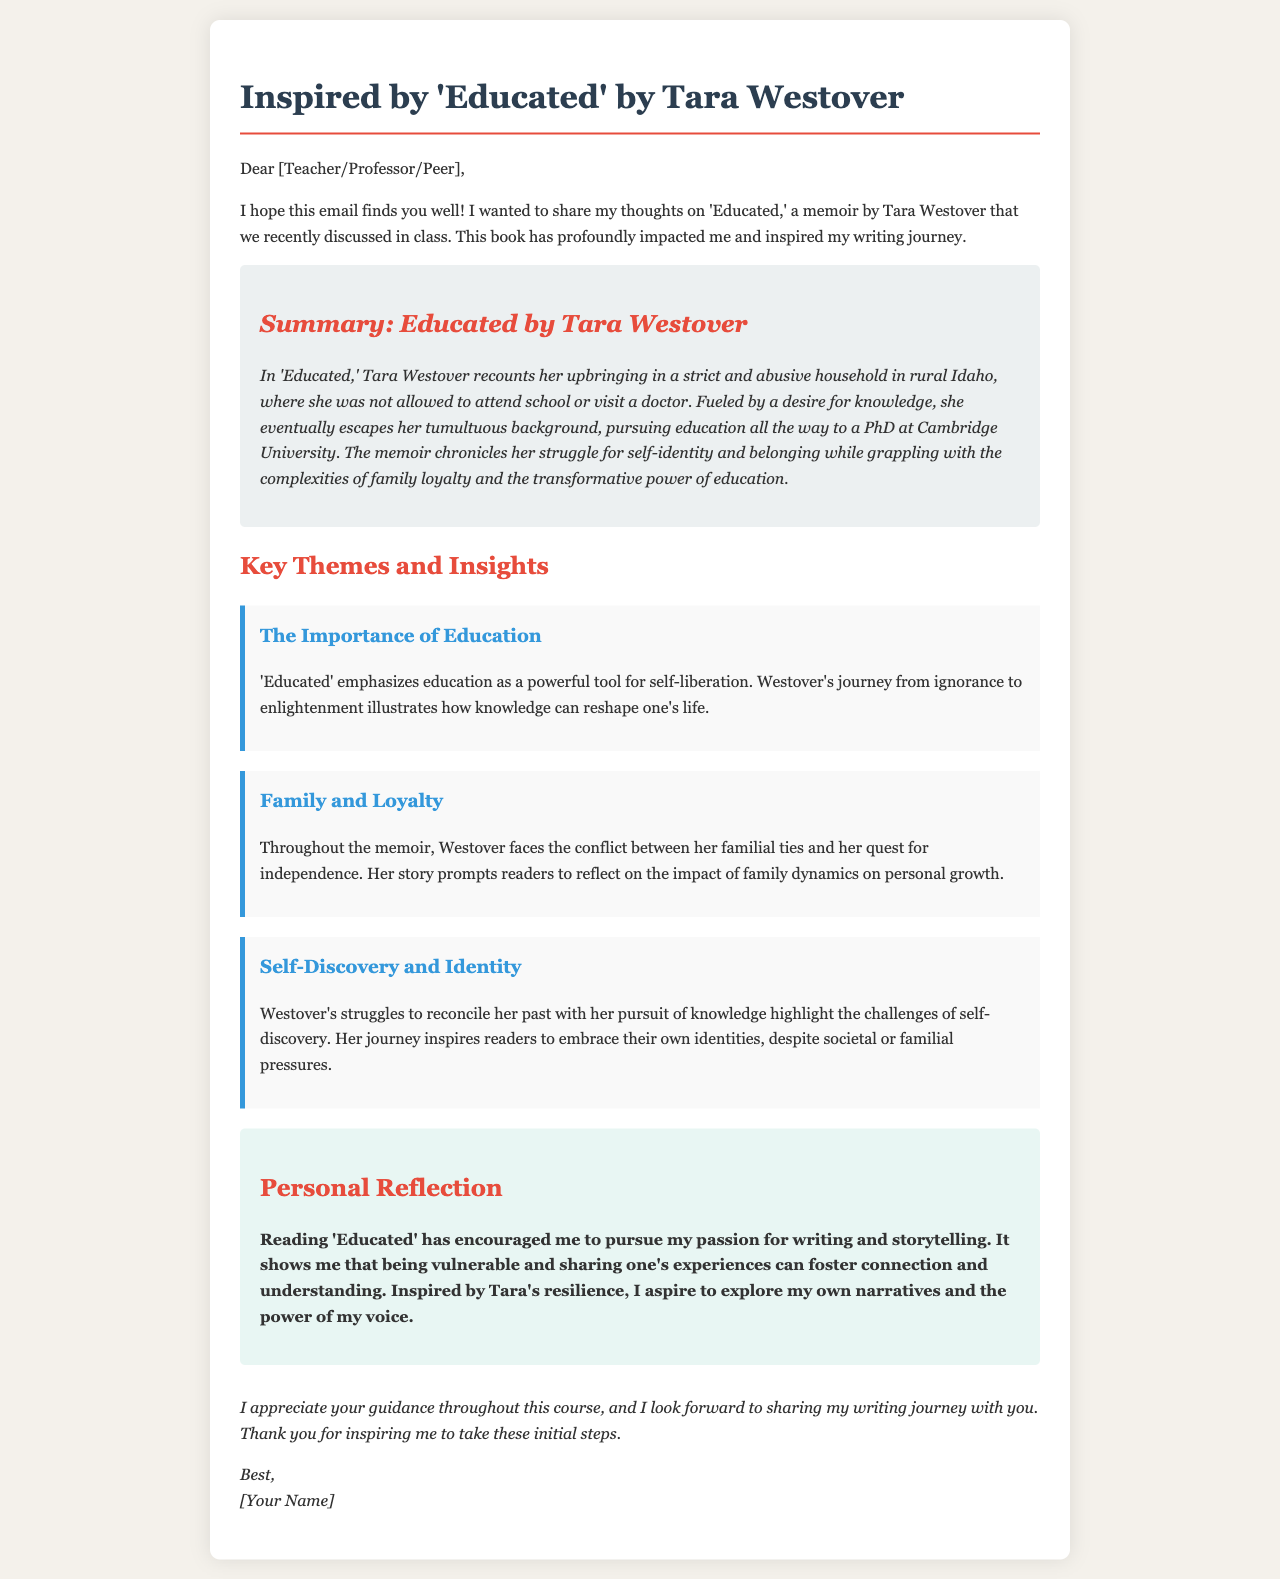What is the title of the memoir discussed? The title of the memoir mentioned in the document is 'Educated'.
Answer: 'Educated' Who is the author of the memoir? The author of the memoir is Tara Westover.
Answer: Tara Westover What is one of the key themes highlighted in the document? One of the key themes highlighted is the importance of education.
Answer: Importance of Education What degree did Tara Westover earn? Tara Westover earned a PhD.
Answer: PhD What impact did reading 'Educated' have on the author of the email? Reading 'Educated' encouraged the author to pursue writing and storytelling.
Answer: Pursue writing and storytelling How does the document's structure categorize different parts? The document categorizes parts with headings and sections, such as "Summary," "Key Themes and Insights," and "Personal Reflection."
Answer: Headings and sections What familial conflict does Westover face according to the email? Westover faces a conflict between her familial ties and her quest for independence.
Answer: Familial ties and independence What style is used for the personal reflection section? The personal reflection section uses a bold font style.
Answer: Bold font style 